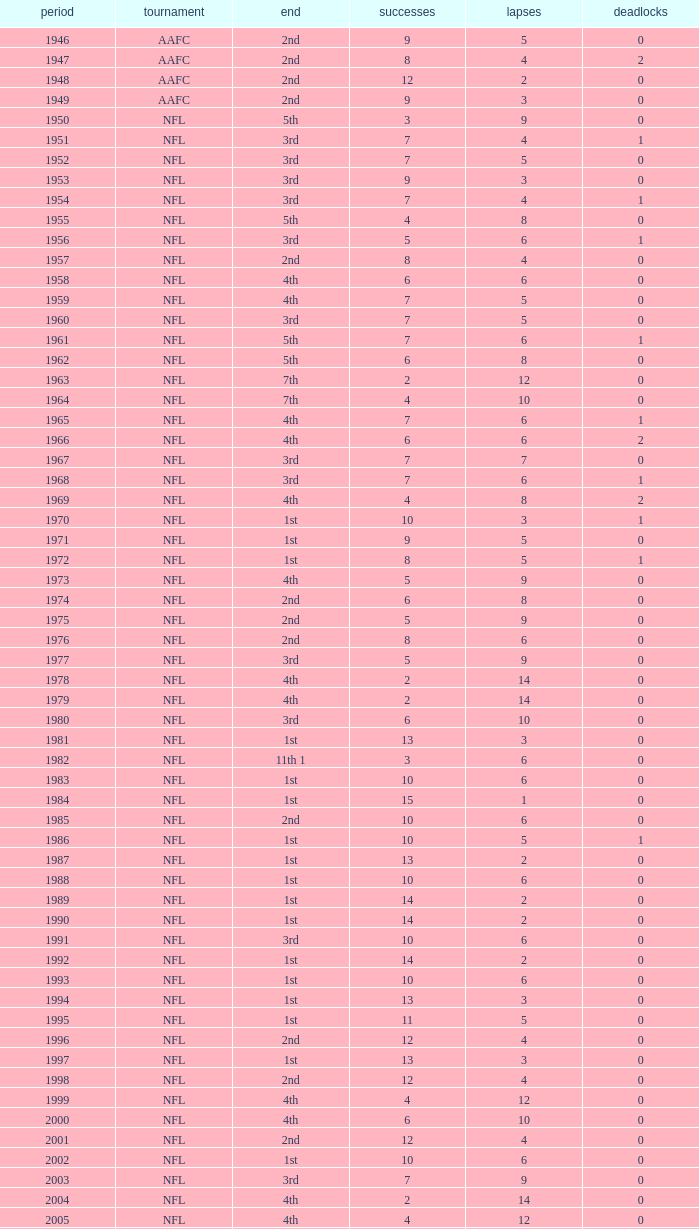What league had a finish of 2nd and 3 losses? AAFC. 